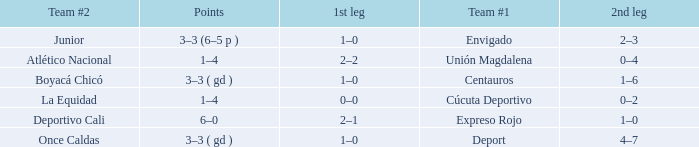What is the 2nd leg for the team #2 junior? 2–3. Parse the table in full. {'header': ['Team #2', 'Points', '1st leg', 'Team #1', '2nd leg'], 'rows': [['Junior', '3–3 (6–5 p )', '1–0', 'Envigado', '2–3'], ['Atlético Nacional', '1–4', '2–2', 'Unión Magdalena', '0–4'], ['Boyacá Chicó', '3–3 ( gd )', '1–0', 'Centauros', '1–6'], ['La Equidad', '1–4', '0–0', 'Cúcuta Deportivo', '0–2'], ['Deportivo Cali', '6–0', '2–1', 'Expreso Rojo', '1–0'], ['Once Caldas', '3–3 ( gd )', '1–0', 'Deport', '4–7']]} 